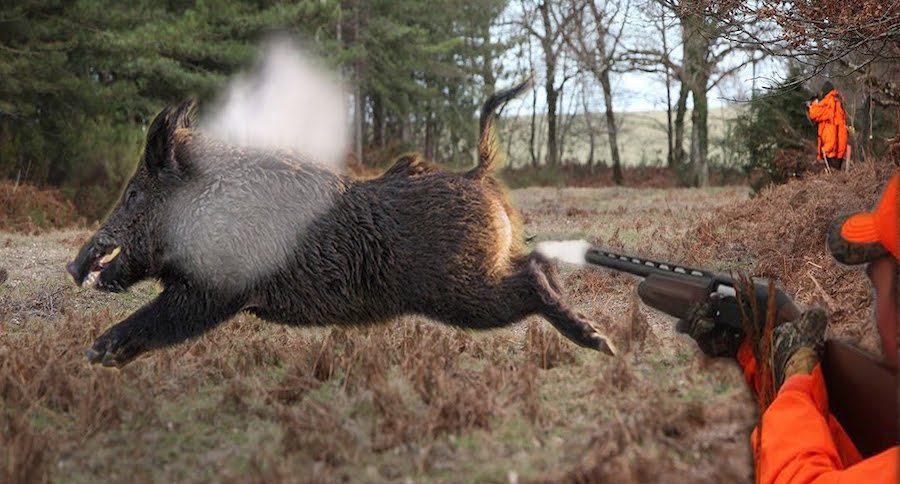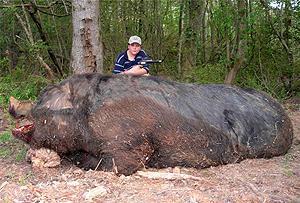The first image is the image on the left, the second image is the image on the right. Considering the images on both sides, is "One of the image features one man next to a dead wild boar." valid? Answer yes or no. Yes. 